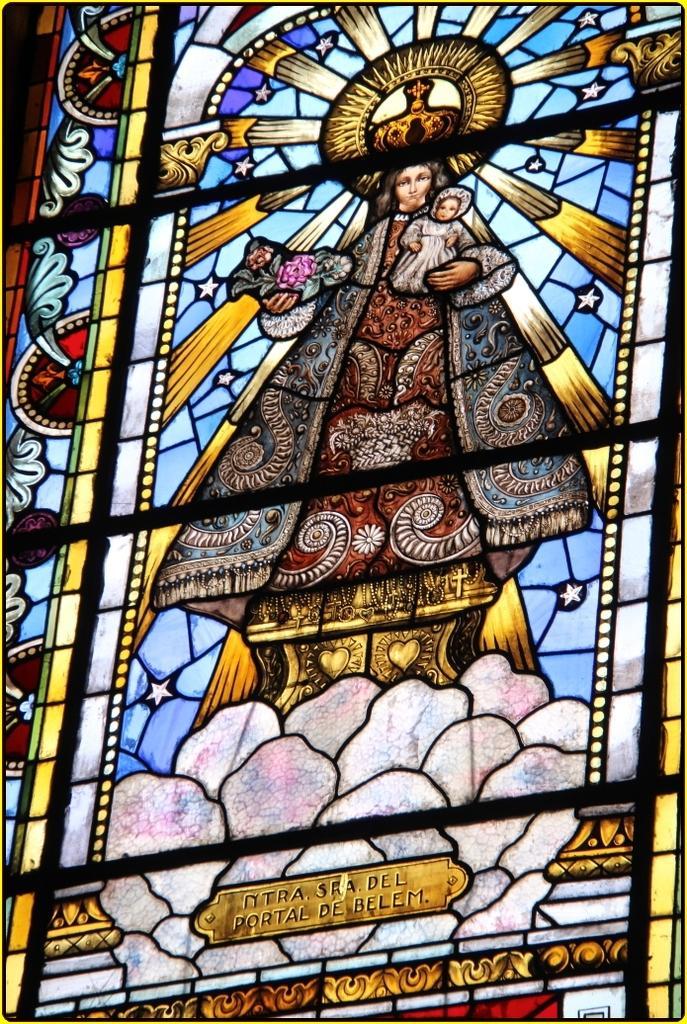In one or two sentences, can you explain what this image depicts? In this image there is a glass on that glass there is a jesus painting. 